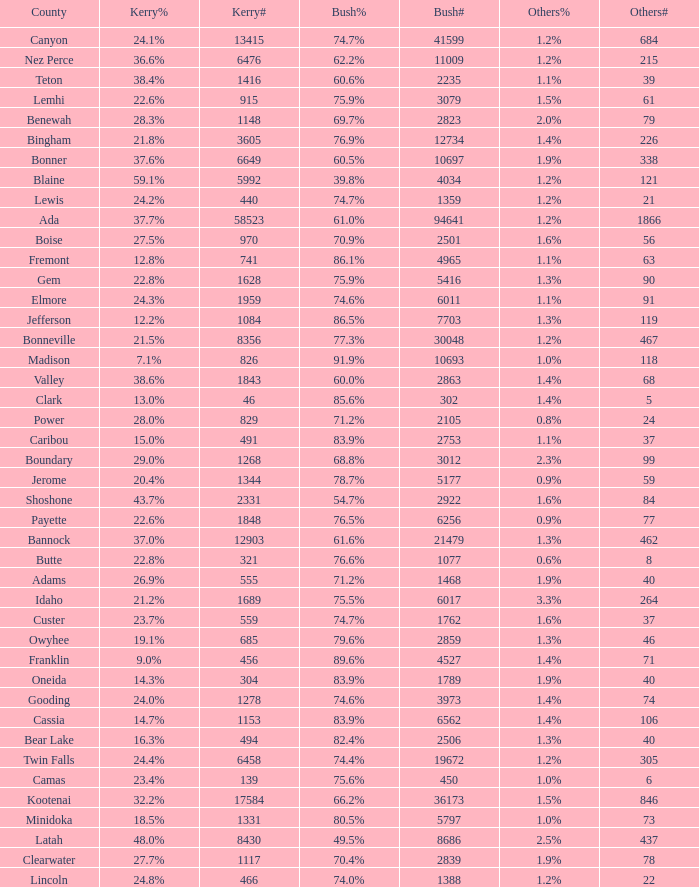What percentage of the people in Bonneville voted for Bush? 77.3%. 